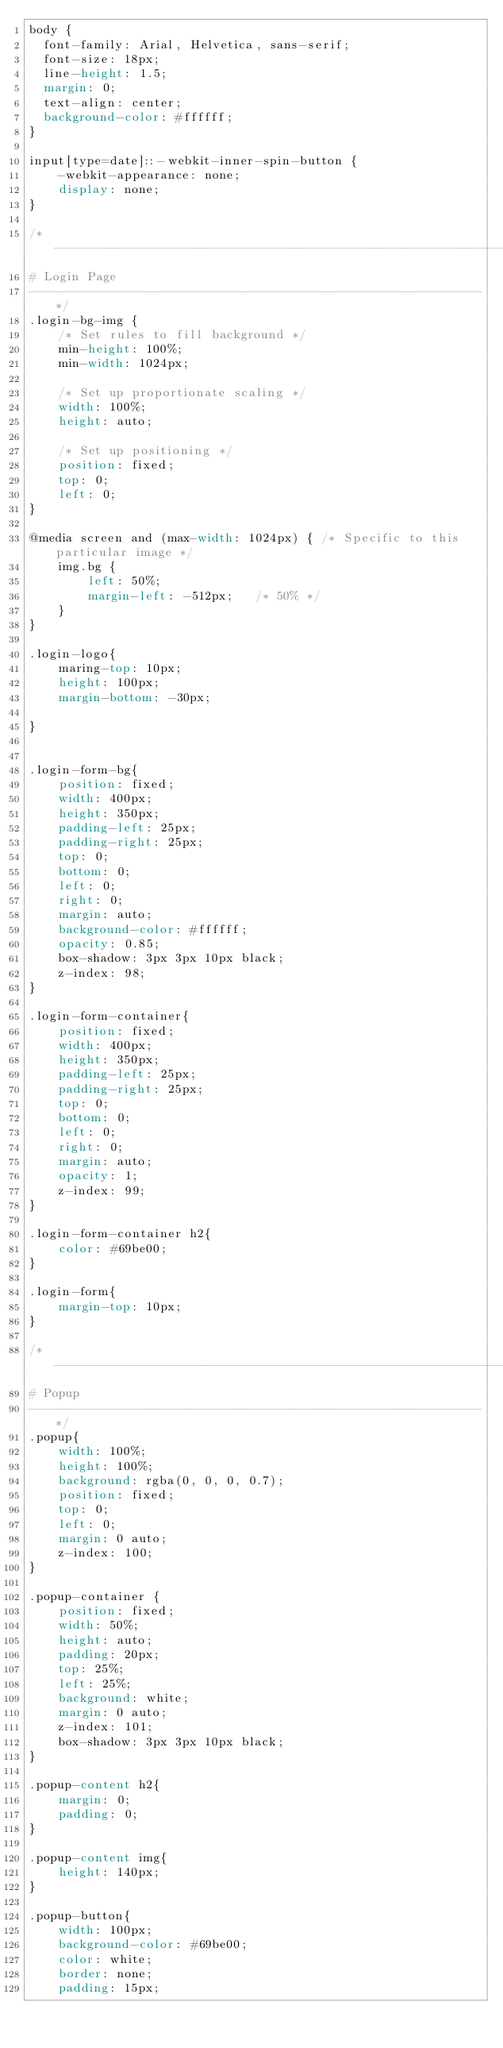<code> <loc_0><loc_0><loc_500><loc_500><_CSS_>body {
	font-family: Arial, Helvetica, sans-serif;
	font-size: 18px;
	line-height: 1.5;
	margin: 0;
	text-align: center;
	background-color: #ffffff;
}

input[type=date]::-webkit-inner-spin-button {
    -webkit-appearance: none;
    display: none;
}

/*--------------------------------------------------------------
# Login Page
--------------------------------------------------------------*/
.login-bg-img {
    /* Set rules to fill background */
    min-height: 100%;
    min-width: 1024px;

    /* Set up proportionate scaling */
    width: 100%;
    height: auto;

    /* Set up positioning */
    position: fixed;
    top: 0;
    left: 0;
}

@media screen and (max-width: 1024px) { /* Specific to this particular image */
    img.bg {
        left: 50%;
        margin-left: -512px;   /* 50% */
    }
}

.login-logo{
    maring-top: 10px;
    height: 100px;
    margin-bottom: -30px;

}


.login-form-bg{
    position: fixed;
    width: 400px;
    height: 350px;
    padding-left: 25px;
    padding-right: 25px;
    top: 0;
    bottom: 0;
    left: 0;
    right: 0;
    margin: auto;
    background-color: #ffffff;
    opacity: 0.85;
    box-shadow: 3px 3px 10px black;
    z-index: 98;
}

.login-form-container{
    position: fixed;
    width: 400px;
    height: 350px;
    padding-left: 25px;
    padding-right: 25px;
    top: 0;
    bottom: 0;
    left: 0;
    right: 0;
    margin: auto;
    opacity: 1;
    z-index: 99;
}

.login-form-container h2{
    color: #69be00;
}

.login-form{
    margin-top: 10px;
}

/*--------------------------------------------------------------
# Popup
--------------------------------------------------------------*/
.popup{
    width: 100%;
    height: 100%;
    background: rgba(0, 0, 0, 0.7);
    position: fixed;
    top: 0;
    left: 0;
    margin: 0 auto;
    z-index: 100;
}

.popup-container {
    position: fixed;
    width: 50%;
    height: auto;
    padding: 20px;
    top: 25%;
    left: 25%;
    background: white;
    margin: 0 auto;
    z-index: 101;
    box-shadow: 3px 3px 10px black;
}

.popup-content h2{
    margin: 0;
    padding: 0;
}

.popup-content img{
    height: 140px;
}

.popup-button{
    width: 100px;
    background-color: #69be00;
    color: white;
    border: none;
    padding: 15px;</code> 